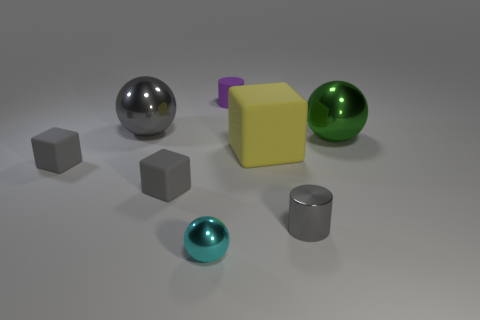Add 1 tiny metal spheres. How many objects exist? 9 Subtract all cubes. How many objects are left? 5 Subtract 0 blue cylinders. How many objects are left? 8 Subtract all small blue rubber cubes. Subtract all cubes. How many objects are left? 5 Add 5 small balls. How many small balls are left? 6 Add 4 small cyan metal spheres. How many small cyan metal spheres exist? 5 